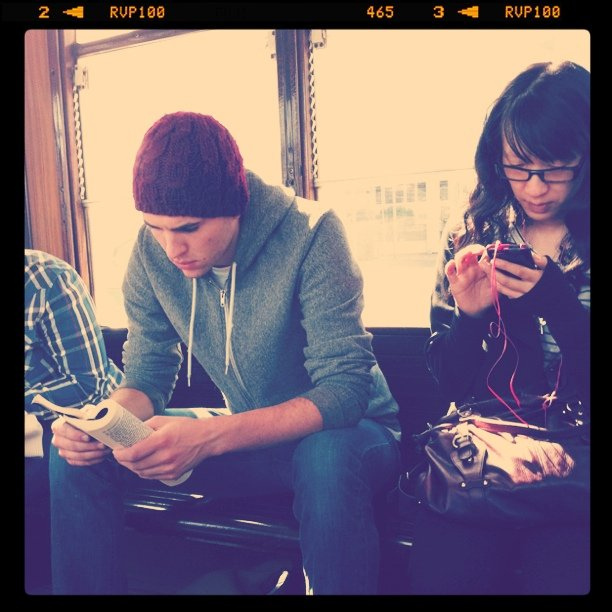Please extract the text content from this image. 465 3 RVP100 RUP100 2 